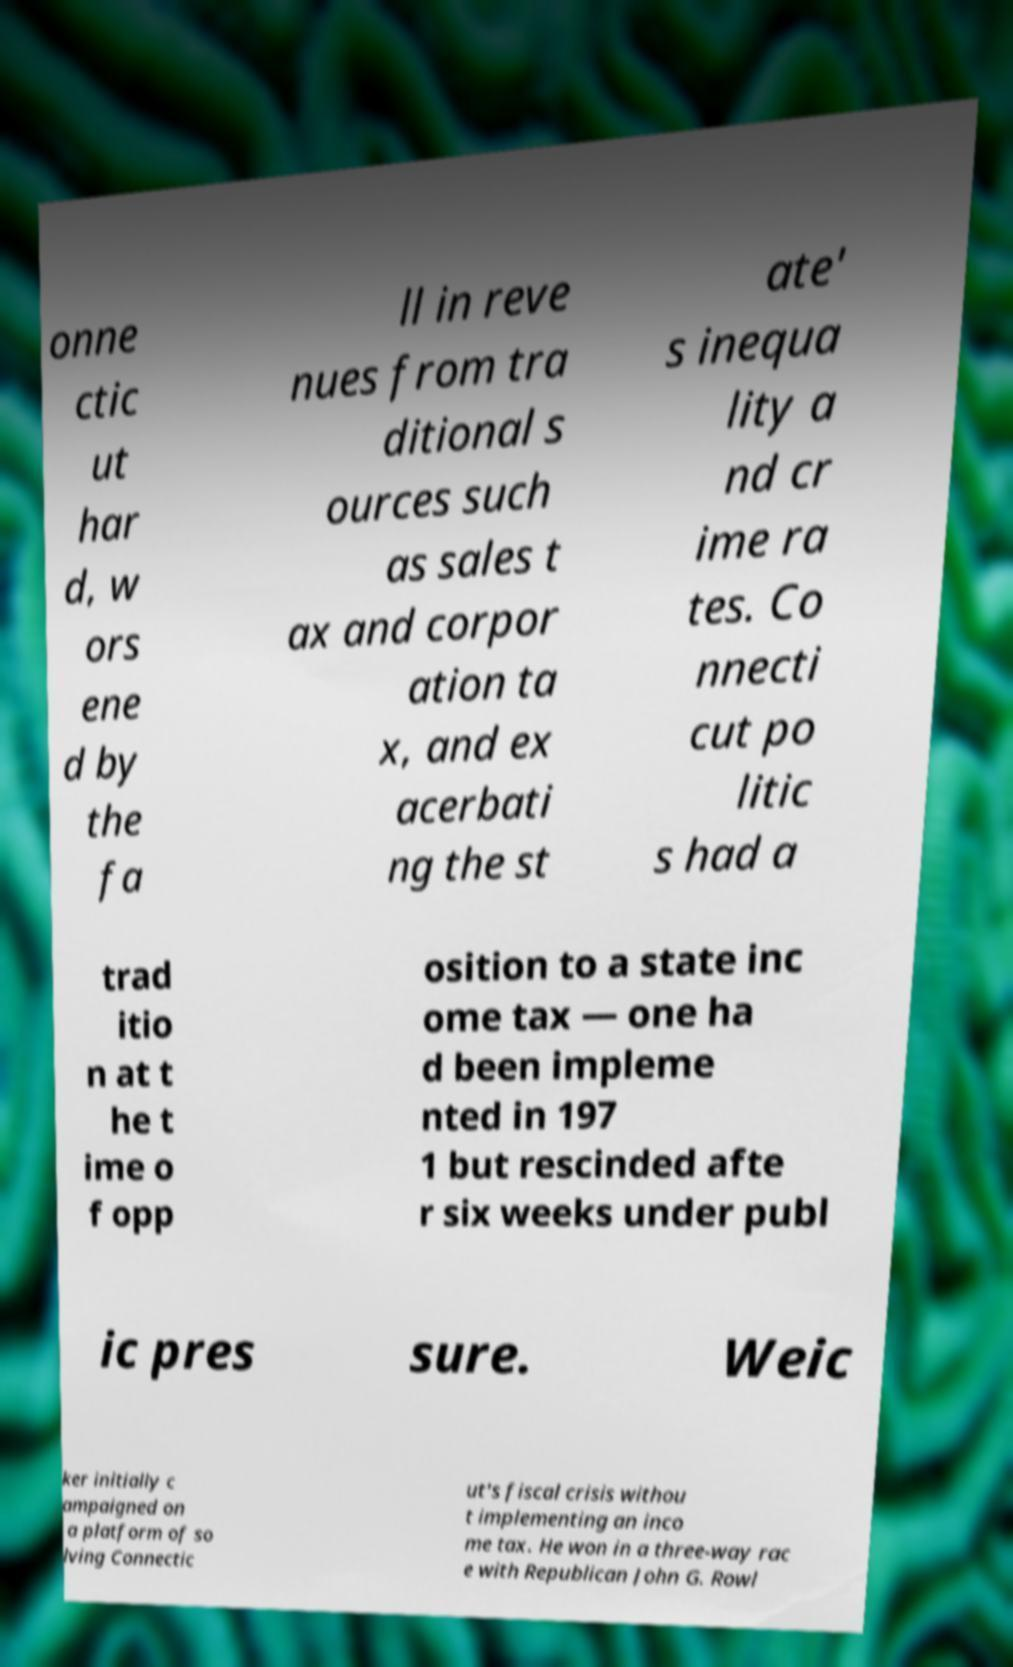Could you extract and type out the text from this image? onne ctic ut har d, w ors ene d by the fa ll in reve nues from tra ditional s ources such as sales t ax and corpor ation ta x, and ex acerbati ng the st ate' s inequa lity a nd cr ime ra tes. Co nnecti cut po litic s had a trad itio n at t he t ime o f opp osition to a state inc ome tax — one ha d been impleme nted in 197 1 but rescinded afte r six weeks under publ ic pres sure. Weic ker initially c ampaigned on a platform of so lving Connectic ut's fiscal crisis withou t implementing an inco me tax. He won in a three-way rac e with Republican John G. Rowl 